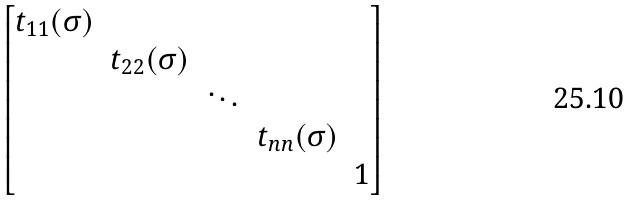<formula> <loc_0><loc_0><loc_500><loc_500>\begin{bmatrix} t _ { 1 1 } ( \sigma ) & & & & \\ & t _ { 2 2 } ( \sigma ) & & & \\ & & \ddots & & \\ & & & t _ { n n } ( \sigma ) & \\ & & & & 1 \\ \end{bmatrix}</formula> 